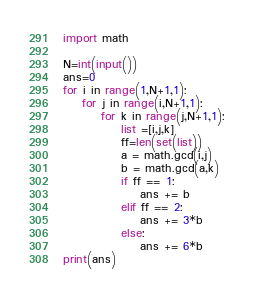Convert code to text. <code><loc_0><loc_0><loc_500><loc_500><_Python_>import math

N=int(input())
ans=0
for i in range(1,N+1,1):
    for j in range(i,N+1,1):
        for k in range(j,N+1,1):
            list =[i,j,k]
            ff=len(set(list))
            a = math.gcd(i,j)
            b = math.gcd(a,k)
            if ff == 1:
                ans += b
            elif ff == 2:
                ans += 3*b
            else:
                ans += 6*b
print(ans)            </code> 